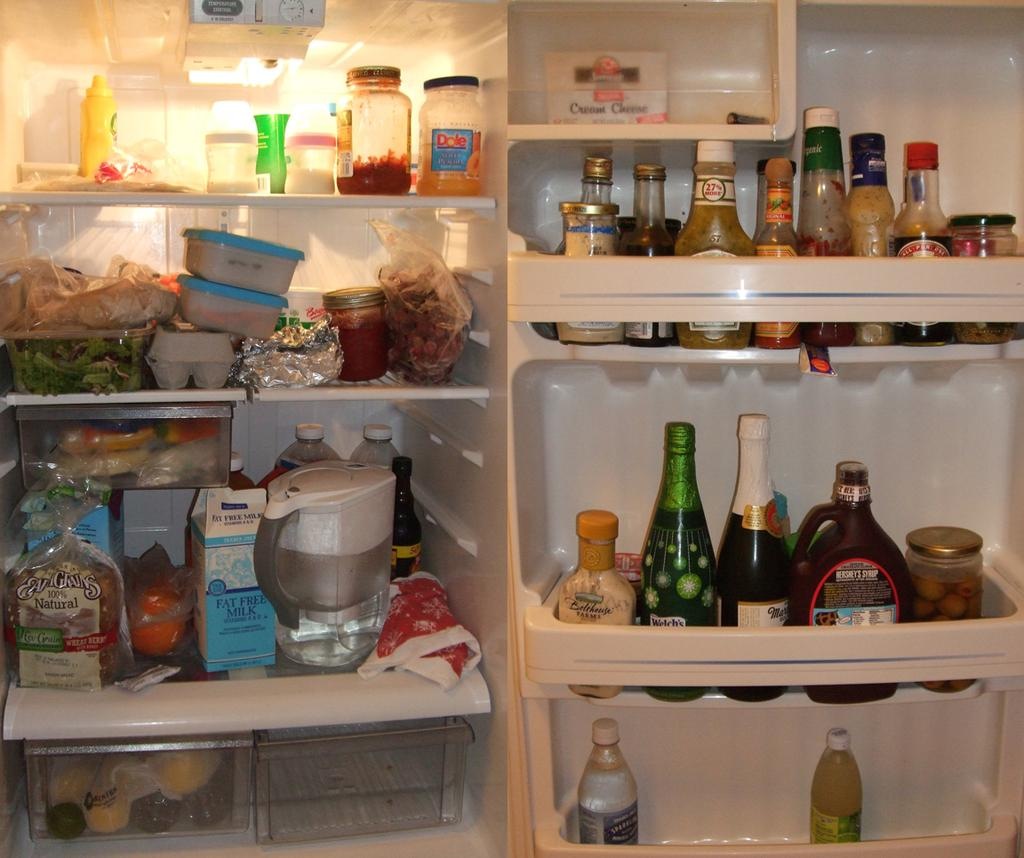<image>
Summarize the visual content of the image. A refrigerator door has a bottle of Hershey's chocolate syrup. 